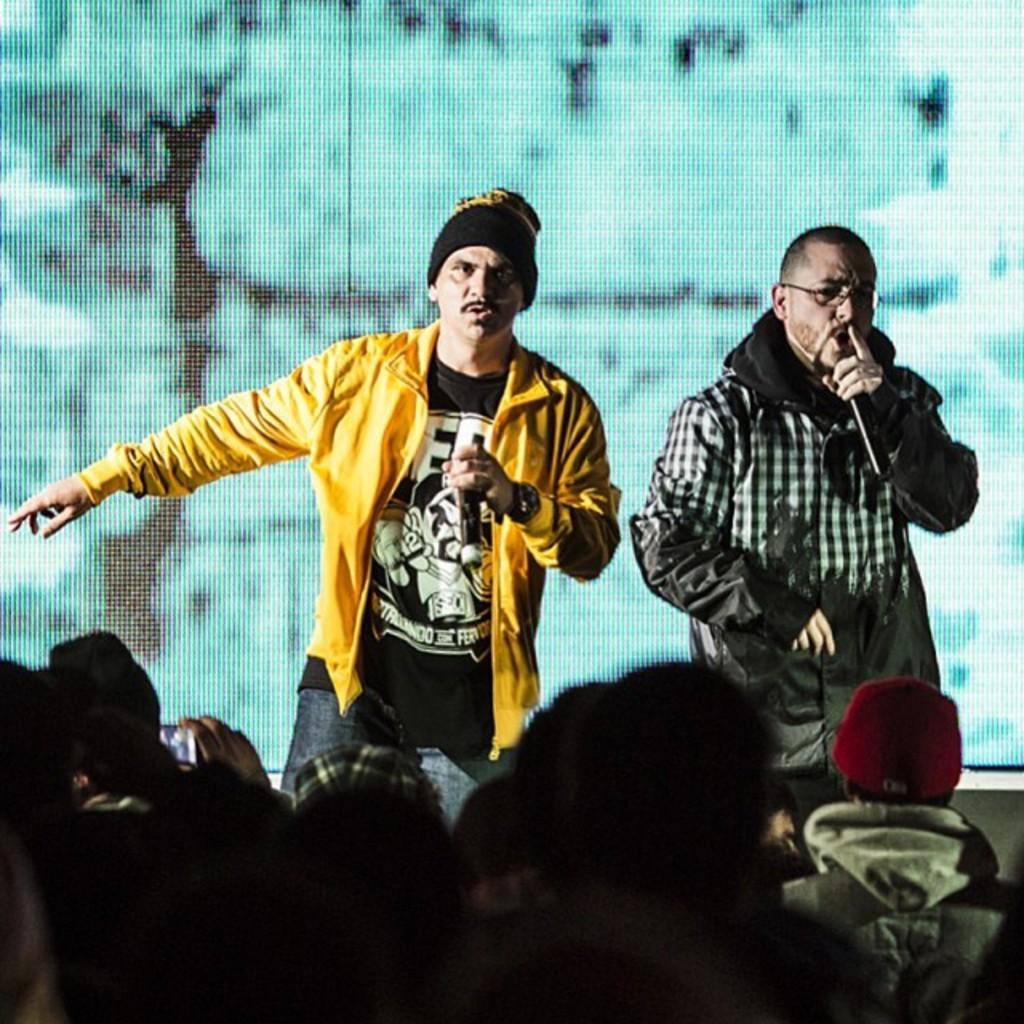Can you describe this image briefly? In this image I can see two people holding the mic and the group of people sitting in-front of them. 